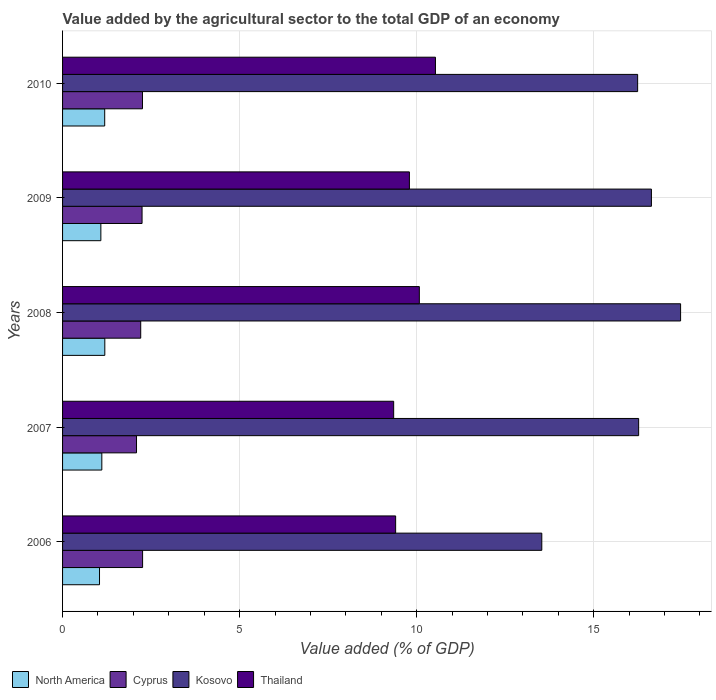How many different coloured bars are there?
Provide a short and direct response. 4. How many groups of bars are there?
Keep it short and to the point. 5. How many bars are there on the 5th tick from the top?
Your answer should be compact. 4. In how many cases, is the number of bars for a given year not equal to the number of legend labels?
Ensure brevity in your answer.  0. What is the value added by the agricultural sector to the total GDP in Cyprus in 2009?
Provide a succinct answer. 2.24. Across all years, what is the maximum value added by the agricultural sector to the total GDP in North America?
Provide a short and direct response. 1.19. Across all years, what is the minimum value added by the agricultural sector to the total GDP in Cyprus?
Keep it short and to the point. 2.09. What is the total value added by the agricultural sector to the total GDP in Thailand in the graph?
Your answer should be compact. 49.16. What is the difference between the value added by the agricultural sector to the total GDP in Kosovo in 2009 and that in 2010?
Offer a very short reply. 0.39. What is the difference between the value added by the agricultural sector to the total GDP in North America in 2010 and the value added by the agricultural sector to the total GDP in Cyprus in 2007?
Provide a short and direct response. -0.9. What is the average value added by the agricultural sector to the total GDP in North America per year?
Ensure brevity in your answer.  1.12. In the year 2007, what is the difference between the value added by the agricultural sector to the total GDP in Thailand and value added by the agricultural sector to the total GDP in Kosovo?
Your answer should be compact. -6.92. In how many years, is the value added by the agricultural sector to the total GDP in Thailand greater than 3 %?
Ensure brevity in your answer.  5. What is the ratio of the value added by the agricultural sector to the total GDP in Thailand in 2006 to that in 2009?
Your answer should be very brief. 0.96. Is the value added by the agricultural sector to the total GDP in North America in 2008 less than that in 2010?
Provide a short and direct response. No. Is the difference between the value added by the agricultural sector to the total GDP in Thailand in 2007 and 2010 greater than the difference between the value added by the agricultural sector to the total GDP in Kosovo in 2007 and 2010?
Your response must be concise. No. What is the difference between the highest and the second highest value added by the agricultural sector to the total GDP in Cyprus?
Your answer should be compact. 0. What is the difference between the highest and the lowest value added by the agricultural sector to the total GDP in North America?
Ensure brevity in your answer.  0.15. Is the sum of the value added by the agricultural sector to the total GDP in Cyprus in 2006 and 2007 greater than the maximum value added by the agricultural sector to the total GDP in North America across all years?
Your answer should be very brief. Yes. Is it the case that in every year, the sum of the value added by the agricultural sector to the total GDP in Cyprus and value added by the agricultural sector to the total GDP in North America is greater than the sum of value added by the agricultural sector to the total GDP in Thailand and value added by the agricultural sector to the total GDP in Kosovo?
Your answer should be compact. No. What does the 1st bar from the bottom in 2007 represents?
Give a very brief answer. North America. Is it the case that in every year, the sum of the value added by the agricultural sector to the total GDP in Cyprus and value added by the agricultural sector to the total GDP in North America is greater than the value added by the agricultural sector to the total GDP in Kosovo?
Offer a very short reply. No. How many years are there in the graph?
Your answer should be very brief. 5. What is the difference between two consecutive major ticks on the X-axis?
Keep it short and to the point. 5. Does the graph contain any zero values?
Your response must be concise. No. Does the graph contain grids?
Keep it short and to the point. Yes. What is the title of the graph?
Provide a succinct answer. Value added by the agricultural sector to the total GDP of an economy. What is the label or title of the X-axis?
Offer a very short reply. Value added (% of GDP). What is the Value added (% of GDP) of North America in 2006?
Offer a very short reply. 1.04. What is the Value added (% of GDP) in Cyprus in 2006?
Provide a short and direct response. 2.26. What is the Value added (% of GDP) of Kosovo in 2006?
Offer a terse response. 13.53. What is the Value added (% of GDP) in Thailand in 2006?
Offer a very short reply. 9.41. What is the Value added (% of GDP) in North America in 2007?
Give a very brief answer. 1.11. What is the Value added (% of GDP) in Cyprus in 2007?
Ensure brevity in your answer.  2.09. What is the Value added (% of GDP) in Kosovo in 2007?
Give a very brief answer. 16.27. What is the Value added (% of GDP) of Thailand in 2007?
Keep it short and to the point. 9.35. What is the Value added (% of GDP) of North America in 2008?
Make the answer very short. 1.19. What is the Value added (% of GDP) in Cyprus in 2008?
Offer a very short reply. 2.21. What is the Value added (% of GDP) in Kosovo in 2008?
Offer a very short reply. 17.45. What is the Value added (% of GDP) in Thailand in 2008?
Your response must be concise. 10.08. What is the Value added (% of GDP) in North America in 2009?
Offer a very short reply. 1.08. What is the Value added (% of GDP) of Cyprus in 2009?
Make the answer very short. 2.24. What is the Value added (% of GDP) of Kosovo in 2009?
Ensure brevity in your answer.  16.63. What is the Value added (% of GDP) in Thailand in 2009?
Your answer should be compact. 9.79. What is the Value added (% of GDP) in North America in 2010?
Ensure brevity in your answer.  1.19. What is the Value added (% of GDP) in Cyprus in 2010?
Keep it short and to the point. 2.26. What is the Value added (% of GDP) in Kosovo in 2010?
Your response must be concise. 16.24. What is the Value added (% of GDP) in Thailand in 2010?
Keep it short and to the point. 10.53. Across all years, what is the maximum Value added (% of GDP) of North America?
Your answer should be compact. 1.19. Across all years, what is the maximum Value added (% of GDP) of Cyprus?
Provide a succinct answer. 2.26. Across all years, what is the maximum Value added (% of GDP) in Kosovo?
Your answer should be compact. 17.45. Across all years, what is the maximum Value added (% of GDP) of Thailand?
Your answer should be compact. 10.53. Across all years, what is the minimum Value added (% of GDP) of North America?
Offer a terse response. 1.04. Across all years, what is the minimum Value added (% of GDP) of Cyprus?
Your answer should be compact. 2.09. Across all years, what is the minimum Value added (% of GDP) of Kosovo?
Make the answer very short. 13.53. Across all years, what is the minimum Value added (% of GDP) of Thailand?
Your response must be concise. 9.35. What is the total Value added (% of GDP) in North America in the graph?
Offer a very short reply. 5.62. What is the total Value added (% of GDP) in Cyprus in the graph?
Provide a short and direct response. 11.06. What is the total Value added (% of GDP) in Kosovo in the graph?
Keep it short and to the point. 80.13. What is the total Value added (% of GDP) in Thailand in the graph?
Your response must be concise. 49.16. What is the difference between the Value added (% of GDP) in North America in 2006 and that in 2007?
Give a very brief answer. -0.07. What is the difference between the Value added (% of GDP) of Cyprus in 2006 and that in 2007?
Offer a very short reply. 0.17. What is the difference between the Value added (% of GDP) in Kosovo in 2006 and that in 2007?
Make the answer very short. -2.73. What is the difference between the Value added (% of GDP) of Thailand in 2006 and that in 2007?
Ensure brevity in your answer.  0.06. What is the difference between the Value added (% of GDP) of North America in 2006 and that in 2008?
Keep it short and to the point. -0.15. What is the difference between the Value added (% of GDP) of Cyprus in 2006 and that in 2008?
Ensure brevity in your answer.  0.05. What is the difference between the Value added (% of GDP) of Kosovo in 2006 and that in 2008?
Provide a short and direct response. -3.92. What is the difference between the Value added (% of GDP) of Thailand in 2006 and that in 2008?
Ensure brevity in your answer.  -0.67. What is the difference between the Value added (% of GDP) of North America in 2006 and that in 2009?
Your answer should be very brief. -0.04. What is the difference between the Value added (% of GDP) of Cyprus in 2006 and that in 2009?
Make the answer very short. 0.02. What is the difference between the Value added (% of GDP) in Kosovo in 2006 and that in 2009?
Keep it short and to the point. -3.1. What is the difference between the Value added (% of GDP) of Thailand in 2006 and that in 2009?
Keep it short and to the point. -0.39. What is the difference between the Value added (% of GDP) of North America in 2006 and that in 2010?
Give a very brief answer. -0.15. What is the difference between the Value added (% of GDP) of Cyprus in 2006 and that in 2010?
Offer a very short reply. 0. What is the difference between the Value added (% of GDP) in Kosovo in 2006 and that in 2010?
Your response must be concise. -2.71. What is the difference between the Value added (% of GDP) of Thailand in 2006 and that in 2010?
Give a very brief answer. -1.12. What is the difference between the Value added (% of GDP) in North America in 2007 and that in 2008?
Your response must be concise. -0.08. What is the difference between the Value added (% of GDP) in Cyprus in 2007 and that in 2008?
Give a very brief answer. -0.12. What is the difference between the Value added (% of GDP) of Kosovo in 2007 and that in 2008?
Your answer should be compact. -1.18. What is the difference between the Value added (% of GDP) in Thailand in 2007 and that in 2008?
Ensure brevity in your answer.  -0.72. What is the difference between the Value added (% of GDP) of North America in 2007 and that in 2009?
Provide a succinct answer. 0.03. What is the difference between the Value added (% of GDP) in Cyprus in 2007 and that in 2009?
Ensure brevity in your answer.  -0.16. What is the difference between the Value added (% of GDP) in Kosovo in 2007 and that in 2009?
Offer a terse response. -0.36. What is the difference between the Value added (% of GDP) in Thailand in 2007 and that in 2009?
Make the answer very short. -0.44. What is the difference between the Value added (% of GDP) of North America in 2007 and that in 2010?
Give a very brief answer. -0.08. What is the difference between the Value added (% of GDP) of Cyprus in 2007 and that in 2010?
Your answer should be very brief. -0.17. What is the difference between the Value added (% of GDP) in Kosovo in 2007 and that in 2010?
Make the answer very short. 0.03. What is the difference between the Value added (% of GDP) in Thailand in 2007 and that in 2010?
Give a very brief answer. -1.18. What is the difference between the Value added (% of GDP) in North America in 2008 and that in 2009?
Your answer should be compact. 0.11. What is the difference between the Value added (% of GDP) in Cyprus in 2008 and that in 2009?
Offer a terse response. -0.04. What is the difference between the Value added (% of GDP) in Kosovo in 2008 and that in 2009?
Provide a short and direct response. 0.82. What is the difference between the Value added (% of GDP) in Thailand in 2008 and that in 2009?
Offer a very short reply. 0.28. What is the difference between the Value added (% of GDP) of North America in 2008 and that in 2010?
Provide a succinct answer. 0. What is the difference between the Value added (% of GDP) in Cyprus in 2008 and that in 2010?
Ensure brevity in your answer.  -0.05. What is the difference between the Value added (% of GDP) in Kosovo in 2008 and that in 2010?
Offer a terse response. 1.21. What is the difference between the Value added (% of GDP) of Thailand in 2008 and that in 2010?
Provide a succinct answer. -0.46. What is the difference between the Value added (% of GDP) of North America in 2009 and that in 2010?
Provide a succinct answer. -0.11. What is the difference between the Value added (% of GDP) in Cyprus in 2009 and that in 2010?
Provide a succinct answer. -0.01. What is the difference between the Value added (% of GDP) in Kosovo in 2009 and that in 2010?
Your answer should be compact. 0.39. What is the difference between the Value added (% of GDP) in Thailand in 2009 and that in 2010?
Make the answer very short. -0.74. What is the difference between the Value added (% of GDP) of North America in 2006 and the Value added (% of GDP) of Cyprus in 2007?
Your answer should be compact. -1.04. What is the difference between the Value added (% of GDP) in North America in 2006 and the Value added (% of GDP) in Kosovo in 2007?
Give a very brief answer. -15.23. What is the difference between the Value added (% of GDP) in North America in 2006 and the Value added (% of GDP) in Thailand in 2007?
Your answer should be compact. -8.31. What is the difference between the Value added (% of GDP) in Cyprus in 2006 and the Value added (% of GDP) in Kosovo in 2007?
Provide a short and direct response. -14.01. What is the difference between the Value added (% of GDP) in Cyprus in 2006 and the Value added (% of GDP) in Thailand in 2007?
Give a very brief answer. -7.09. What is the difference between the Value added (% of GDP) in Kosovo in 2006 and the Value added (% of GDP) in Thailand in 2007?
Ensure brevity in your answer.  4.18. What is the difference between the Value added (% of GDP) of North America in 2006 and the Value added (% of GDP) of Cyprus in 2008?
Ensure brevity in your answer.  -1.16. What is the difference between the Value added (% of GDP) in North America in 2006 and the Value added (% of GDP) in Kosovo in 2008?
Provide a succinct answer. -16.41. What is the difference between the Value added (% of GDP) of North America in 2006 and the Value added (% of GDP) of Thailand in 2008?
Provide a succinct answer. -9.03. What is the difference between the Value added (% of GDP) of Cyprus in 2006 and the Value added (% of GDP) of Kosovo in 2008?
Provide a succinct answer. -15.19. What is the difference between the Value added (% of GDP) in Cyprus in 2006 and the Value added (% of GDP) in Thailand in 2008?
Your answer should be very brief. -7.82. What is the difference between the Value added (% of GDP) in Kosovo in 2006 and the Value added (% of GDP) in Thailand in 2008?
Your answer should be compact. 3.46. What is the difference between the Value added (% of GDP) of North America in 2006 and the Value added (% of GDP) of Cyprus in 2009?
Give a very brief answer. -1.2. What is the difference between the Value added (% of GDP) in North America in 2006 and the Value added (% of GDP) in Kosovo in 2009?
Offer a very short reply. -15.59. What is the difference between the Value added (% of GDP) in North America in 2006 and the Value added (% of GDP) in Thailand in 2009?
Your answer should be compact. -8.75. What is the difference between the Value added (% of GDP) of Cyprus in 2006 and the Value added (% of GDP) of Kosovo in 2009?
Offer a very short reply. -14.37. What is the difference between the Value added (% of GDP) in Cyprus in 2006 and the Value added (% of GDP) in Thailand in 2009?
Give a very brief answer. -7.53. What is the difference between the Value added (% of GDP) of Kosovo in 2006 and the Value added (% of GDP) of Thailand in 2009?
Provide a short and direct response. 3.74. What is the difference between the Value added (% of GDP) of North America in 2006 and the Value added (% of GDP) of Cyprus in 2010?
Make the answer very short. -1.21. What is the difference between the Value added (% of GDP) of North America in 2006 and the Value added (% of GDP) of Kosovo in 2010?
Offer a terse response. -15.2. What is the difference between the Value added (% of GDP) in North America in 2006 and the Value added (% of GDP) in Thailand in 2010?
Your response must be concise. -9.49. What is the difference between the Value added (% of GDP) in Cyprus in 2006 and the Value added (% of GDP) in Kosovo in 2010?
Give a very brief answer. -13.98. What is the difference between the Value added (% of GDP) in Cyprus in 2006 and the Value added (% of GDP) in Thailand in 2010?
Make the answer very short. -8.27. What is the difference between the Value added (% of GDP) in Kosovo in 2006 and the Value added (% of GDP) in Thailand in 2010?
Provide a short and direct response. 3. What is the difference between the Value added (% of GDP) of North America in 2007 and the Value added (% of GDP) of Cyprus in 2008?
Offer a very short reply. -1.1. What is the difference between the Value added (% of GDP) of North America in 2007 and the Value added (% of GDP) of Kosovo in 2008?
Give a very brief answer. -16.34. What is the difference between the Value added (% of GDP) in North America in 2007 and the Value added (% of GDP) in Thailand in 2008?
Make the answer very short. -8.97. What is the difference between the Value added (% of GDP) in Cyprus in 2007 and the Value added (% of GDP) in Kosovo in 2008?
Your answer should be compact. -15.37. What is the difference between the Value added (% of GDP) of Cyprus in 2007 and the Value added (% of GDP) of Thailand in 2008?
Your answer should be compact. -7.99. What is the difference between the Value added (% of GDP) of Kosovo in 2007 and the Value added (% of GDP) of Thailand in 2008?
Your response must be concise. 6.19. What is the difference between the Value added (% of GDP) of North America in 2007 and the Value added (% of GDP) of Cyprus in 2009?
Your answer should be very brief. -1.14. What is the difference between the Value added (% of GDP) of North America in 2007 and the Value added (% of GDP) of Kosovo in 2009?
Give a very brief answer. -15.52. What is the difference between the Value added (% of GDP) in North America in 2007 and the Value added (% of GDP) in Thailand in 2009?
Your answer should be very brief. -8.69. What is the difference between the Value added (% of GDP) of Cyprus in 2007 and the Value added (% of GDP) of Kosovo in 2009?
Provide a short and direct response. -14.54. What is the difference between the Value added (% of GDP) of Cyprus in 2007 and the Value added (% of GDP) of Thailand in 2009?
Offer a terse response. -7.71. What is the difference between the Value added (% of GDP) of Kosovo in 2007 and the Value added (% of GDP) of Thailand in 2009?
Your answer should be compact. 6.47. What is the difference between the Value added (% of GDP) in North America in 2007 and the Value added (% of GDP) in Cyprus in 2010?
Offer a very short reply. -1.15. What is the difference between the Value added (% of GDP) in North America in 2007 and the Value added (% of GDP) in Kosovo in 2010?
Your answer should be compact. -15.13. What is the difference between the Value added (% of GDP) of North America in 2007 and the Value added (% of GDP) of Thailand in 2010?
Give a very brief answer. -9.42. What is the difference between the Value added (% of GDP) in Cyprus in 2007 and the Value added (% of GDP) in Kosovo in 2010?
Provide a short and direct response. -14.15. What is the difference between the Value added (% of GDP) in Cyprus in 2007 and the Value added (% of GDP) in Thailand in 2010?
Provide a short and direct response. -8.44. What is the difference between the Value added (% of GDP) in Kosovo in 2007 and the Value added (% of GDP) in Thailand in 2010?
Ensure brevity in your answer.  5.74. What is the difference between the Value added (% of GDP) of North America in 2008 and the Value added (% of GDP) of Cyprus in 2009?
Your response must be concise. -1.05. What is the difference between the Value added (% of GDP) in North America in 2008 and the Value added (% of GDP) in Kosovo in 2009?
Provide a short and direct response. -15.44. What is the difference between the Value added (% of GDP) of North America in 2008 and the Value added (% of GDP) of Thailand in 2009?
Offer a terse response. -8.6. What is the difference between the Value added (% of GDP) in Cyprus in 2008 and the Value added (% of GDP) in Kosovo in 2009?
Offer a terse response. -14.42. What is the difference between the Value added (% of GDP) of Cyprus in 2008 and the Value added (% of GDP) of Thailand in 2009?
Offer a very short reply. -7.59. What is the difference between the Value added (% of GDP) in Kosovo in 2008 and the Value added (% of GDP) in Thailand in 2009?
Offer a very short reply. 7.66. What is the difference between the Value added (% of GDP) of North America in 2008 and the Value added (% of GDP) of Cyprus in 2010?
Provide a short and direct response. -1.06. What is the difference between the Value added (% of GDP) in North America in 2008 and the Value added (% of GDP) in Kosovo in 2010?
Your response must be concise. -15.05. What is the difference between the Value added (% of GDP) in North America in 2008 and the Value added (% of GDP) in Thailand in 2010?
Provide a short and direct response. -9.34. What is the difference between the Value added (% of GDP) in Cyprus in 2008 and the Value added (% of GDP) in Kosovo in 2010?
Ensure brevity in your answer.  -14.03. What is the difference between the Value added (% of GDP) in Cyprus in 2008 and the Value added (% of GDP) in Thailand in 2010?
Ensure brevity in your answer.  -8.32. What is the difference between the Value added (% of GDP) in Kosovo in 2008 and the Value added (% of GDP) in Thailand in 2010?
Your answer should be compact. 6.92. What is the difference between the Value added (% of GDP) in North America in 2009 and the Value added (% of GDP) in Cyprus in 2010?
Your response must be concise. -1.18. What is the difference between the Value added (% of GDP) of North America in 2009 and the Value added (% of GDP) of Kosovo in 2010?
Offer a very short reply. -15.16. What is the difference between the Value added (% of GDP) of North America in 2009 and the Value added (% of GDP) of Thailand in 2010?
Give a very brief answer. -9.45. What is the difference between the Value added (% of GDP) of Cyprus in 2009 and the Value added (% of GDP) of Kosovo in 2010?
Keep it short and to the point. -14. What is the difference between the Value added (% of GDP) of Cyprus in 2009 and the Value added (% of GDP) of Thailand in 2010?
Keep it short and to the point. -8.29. What is the difference between the Value added (% of GDP) of Kosovo in 2009 and the Value added (% of GDP) of Thailand in 2010?
Offer a very short reply. 6.1. What is the average Value added (% of GDP) of North America per year?
Provide a succinct answer. 1.12. What is the average Value added (% of GDP) in Cyprus per year?
Your answer should be very brief. 2.21. What is the average Value added (% of GDP) of Kosovo per year?
Make the answer very short. 16.03. What is the average Value added (% of GDP) in Thailand per year?
Keep it short and to the point. 9.83. In the year 2006, what is the difference between the Value added (% of GDP) in North America and Value added (% of GDP) in Cyprus?
Offer a terse response. -1.22. In the year 2006, what is the difference between the Value added (% of GDP) in North America and Value added (% of GDP) in Kosovo?
Your answer should be compact. -12.49. In the year 2006, what is the difference between the Value added (% of GDP) of North America and Value added (% of GDP) of Thailand?
Your answer should be very brief. -8.36. In the year 2006, what is the difference between the Value added (% of GDP) in Cyprus and Value added (% of GDP) in Kosovo?
Offer a terse response. -11.27. In the year 2006, what is the difference between the Value added (% of GDP) in Cyprus and Value added (% of GDP) in Thailand?
Your response must be concise. -7.15. In the year 2006, what is the difference between the Value added (% of GDP) in Kosovo and Value added (% of GDP) in Thailand?
Make the answer very short. 4.13. In the year 2007, what is the difference between the Value added (% of GDP) of North America and Value added (% of GDP) of Cyprus?
Keep it short and to the point. -0.98. In the year 2007, what is the difference between the Value added (% of GDP) of North America and Value added (% of GDP) of Kosovo?
Keep it short and to the point. -15.16. In the year 2007, what is the difference between the Value added (% of GDP) of North America and Value added (% of GDP) of Thailand?
Your answer should be very brief. -8.24. In the year 2007, what is the difference between the Value added (% of GDP) in Cyprus and Value added (% of GDP) in Kosovo?
Make the answer very short. -14.18. In the year 2007, what is the difference between the Value added (% of GDP) of Cyprus and Value added (% of GDP) of Thailand?
Your response must be concise. -7.26. In the year 2007, what is the difference between the Value added (% of GDP) in Kosovo and Value added (% of GDP) in Thailand?
Give a very brief answer. 6.92. In the year 2008, what is the difference between the Value added (% of GDP) in North America and Value added (% of GDP) in Cyprus?
Make the answer very short. -1.01. In the year 2008, what is the difference between the Value added (% of GDP) of North America and Value added (% of GDP) of Kosovo?
Your response must be concise. -16.26. In the year 2008, what is the difference between the Value added (% of GDP) in North America and Value added (% of GDP) in Thailand?
Your answer should be very brief. -8.88. In the year 2008, what is the difference between the Value added (% of GDP) of Cyprus and Value added (% of GDP) of Kosovo?
Offer a terse response. -15.25. In the year 2008, what is the difference between the Value added (% of GDP) in Cyprus and Value added (% of GDP) in Thailand?
Offer a terse response. -7.87. In the year 2008, what is the difference between the Value added (% of GDP) of Kosovo and Value added (% of GDP) of Thailand?
Provide a succinct answer. 7.38. In the year 2009, what is the difference between the Value added (% of GDP) in North America and Value added (% of GDP) in Cyprus?
Provide a short and direct response. -1.16. In the year 2009, what is the difference between the Value added (% of GDP) in North America and Value added (% of GDP) in Kosovo?
Your answer should be very brief. -15.55. In the year 2009, what is the difference between the Value added (% of GDP) in North America and Value added (% of GDP) in Thailand?
Give a very brief answer. -8.71. In the year 2009, what is the difference between the Value added (% of GDP) in Cyprus and Value added (% of GDP) in Kosovo?
Your answer should be very brief. -14.38. In the year 2009, what is the difference between the Value added (% of GDP) in Cyprus and Value added (% of GDP) in Thailand?
Keep it short and to the point. -7.55. In the year 2009, what is the difference between the Value added (% of GDP) of Kosovo and Value added (% of GDP) of Thailand?
Your answer should be very brief. 6.83. In the year 2010, what is the difference between the Value added (% of GDP) in North America and Value added (% of GDP) in Cyprus?
Ensure brevity in your answer.  -1.07. In the year 2010, what is the difference between the Value added (% of GDP) in North America and Value added (% of GDP) in Kosovo?
Provide a short and direct response. -15.05. In the year 2010, what is the difference between the Value added (% of GDP) in North America and Value added (% of GDP) in Thailand?
Provide a short and direct response. -9.34. In the year 2010, what is the difference between the Value added (% of GDP) of Cyprus and Value added (% of GDP) of Kosovo?
Give a very brief answer. -13.98. In the year 2010, what is the difference between the Value added (% of GDP) of Cyprus and Value added (% of GDP) of Thailand?
Keep it short and to the point. -8.27. In the year 2010, what is the difference between the Value added (% of GDP) in Kosovo and Value added (% of GDP) in Thailand?
Provide a short and direct response. 5.71. What is the ratio of the Value added (% of GDP) in North America in 2006 to that in 2007?
Your answer should be very brief. 0.94. What is the ratio of the Value added (% of GDP) of Cyprus in 2006 to that in 2007?
Give a very brief answer. 1.08. What is the ratio of the Value added (% of GDP) in Kosovo in 2006 to that in 2007?
Your response must be concise. 0.83. What is the ratio of the Value added (% of GDP) in Thailand in 2006 to that in 2007?
Your answer should be very brief. 1.01. What is the ratio of the Value added (% of GDP) of North America in 2006 to that in 2008?
Your answer should be very brief. 0.87. What is the ratio of the Value added (% of GDP) of Cyprus in 2006 to that in 2008?
Give a very brief answer. 1.02. What is the ratio of the Value added (% of GDP) of Kosovo in 2006 to that in 2008?
Give a very brief answer. 0.78. What is the ratio of the Value added (% of GDP) of Thailand in 2006 to that in 2008?
Ensure brevity in your answer.  0.93. What is the ratio of the Value added (% of GDP) in North America in 2006 to that in 2009?
Make the answer very short. 0.96. What is the ratio of the Value added (% of GDP) of Cyprus in 2006 to that in 2009?
Ensure brevity in your answer.  1.01. What is the ratio of the Value added (% of GDP) of Kosovo in 2006 to that in 2009?
Provide a succinct answer. 0.81. What is the ratio of the Value added (% of GDP) in Thailand in 2006 to that in 2009?
Offer a very short reply. 0.96. What is the ratio of the Value added (% of GDP) of North America in 2006 to that in 2010?
Your answer should be very brief. 0.88. What is the ratio of the Value added (% of GDP) of Cyprus in 2006 to that in 2010?
Offer a terse response. 1. What is the ratio of the Value added (% of GDP) in Kosovo in 2006 to that in 2010?
Your response must be concise. 0.83. What is the ratio of the Value added (% of GDP) of Thailand in 2006 to that in 2010?
Keep it short and to the point. 0.89. What is the ratio of the Value added (% of GDP) in North America in 2007 to that in 2008?
Your response must be concise. 0.93. What is the ratio of the Value added (% of GDP) in Cyprus in 2007 to that in 2008?
Ensure brevity in your answer.  0.95. What is the ratio of the Value added (% of GDP) of Kosovo in 2007 to that in 2008?
Your answer should be very brief. 0.93. What is the ratio of the Value added (% of GDP) in Thailand in 2007 to that in 2008?
Offer a terse response. 0.93. What is the ratio of the Value added (% of GDP) in North America in 2007 to that in 2009?
Your response must be concise. 1.03. What is the ratio of the Value added (% of GDP) in Cyprus in 2007 to that in 2009?
Keep it short and to the point. 0.93. What is the ratio of the Value added (% of GDP) of Kosovo in 2007 to that in 2009?
Give a very brief answer. 0.98. What is the ratio of the Value added (% of GDP) in Thailand in 2007 to that in 2009?
Offer a terse response. 0.95. What is the ratio of the Value added (% of GDP) of North America in 2007 to that in 2010?
Provide a succinct answer. 0.93. What is the ratio of the Value added (% of GDP) in Cyprus in 2007 to that in 2010?
Your answer should be compact. 0.93. What is the ratio of the Value added (% of GDP) in Thailand in 2007 to that in 2010?
Your answer should be very brief. 0.89. What is the ratio of the Value added (% of GDP) in North America in 2008 to that in 2009?
Your answer should be very brief. 1.1. What is the ratio of the Value added (% of GDP) of Cyprus in 2008 to that in 2009?
Make the answer very short. 0.98. What is the ratio of the Value added (% of GDP) in Kosovo in 2008 to that in 2009?
Make the answer very short. 1.05. What is the ratio of the Value added (% of GDP) of Thailand in 2008 to that in 2009?
Your response must be concise. 1.03. What is the ratio of the Value added (% of GDP) of North America in 2008 to that in 2010?
Keep it short and to the point. 1. What is the ratio of the Value added (% of GDP) in Cyprus in 2008 to that in 2010?
Provide a succinct answer. 0.98. What is the ratio of the Value added (% of GDP) in Kosovo in 2008 to that in 2010?
Provide a succinct answer. 1.07. What is the ratio of the Value added (% of GDP) in Thailand in 2008 to that in 2010?
Your answer should be compact. 0.96. What is the ratio of the Value added (% of GDP) of North America in 2009 to that in 2010?
Your answer should be very brief. 0.91. What is the ratio of the Value added (% of GDP) in Thailand in 2009 to that in 2010?
Your answer should be compact. 0.93. What is the difference between the highest and the second highest Value added (% of GDP) of North America?
Make the answer very short. 0. What is the difference between the highest and the second highest Value added (% of GDP) of Cyprus?
Provide a short and direct response. 0. What is the difference between the highest and the second highest Value added (% of GDP) of Kosovo?
Your response must be concise. 0.82. What is the difference between the highest and the second highest Value added (% of GDP) in Thailand?
Make the answer very short. 0.46. What is the difference between the highest and the lowest Value added (% of GDP) of North America?
Give a very brief answer. 0.15. What is the difference between the highest and the lowest Value added (% of GDP) in Cyprus?
Your answer should be compact. 0.17. What is the difference between the highest and the lowest Value added (% of GDP) of Kosovo?
Your answer should be compact. 3.92. What is the difference between the highest and the lowest Value added (% of GDP) of Thailand?
Ensure brevity in your answer.  1.18. 